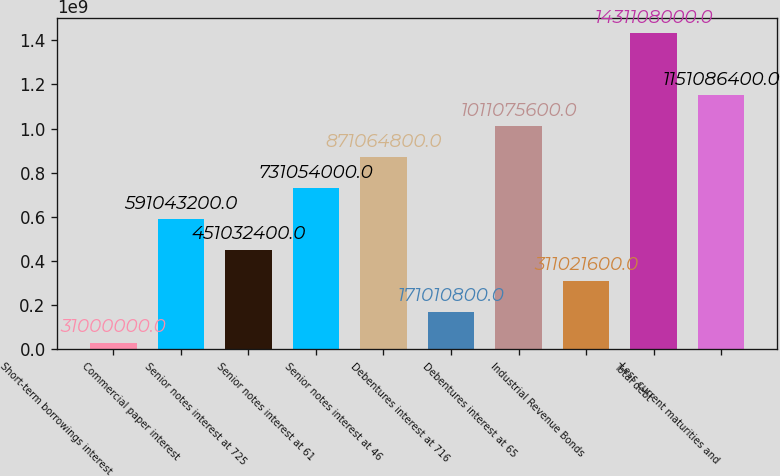<chart> <loc_0><loc_0><loc_500><loc_500><bar_chart><fcel>Short-term borrowings interest<fcel>Commercial paper interest<fcel>Senior notes interest at 725<fcel>Senior notes interest at 61<fcel>Senior notes interest at 46<fcel>Debentures interest at 716<fcel>Debentures interest at 65<fcel>Industrial Revenue Bonds<fcel>Total debt<fcel>Less current maturities and<nl><fcel>3.1e+07<fcel>5.91043e+08<fcel>4.51032e+08<fcel>7.31054e+08<fcel>8.71065e+08<fcel>1.71011e+08<fcel>1.01108e+09<fcel>3.11022e+08<fcel>1.43111e+09<fcel>1.15109e+09<nl></chart> 